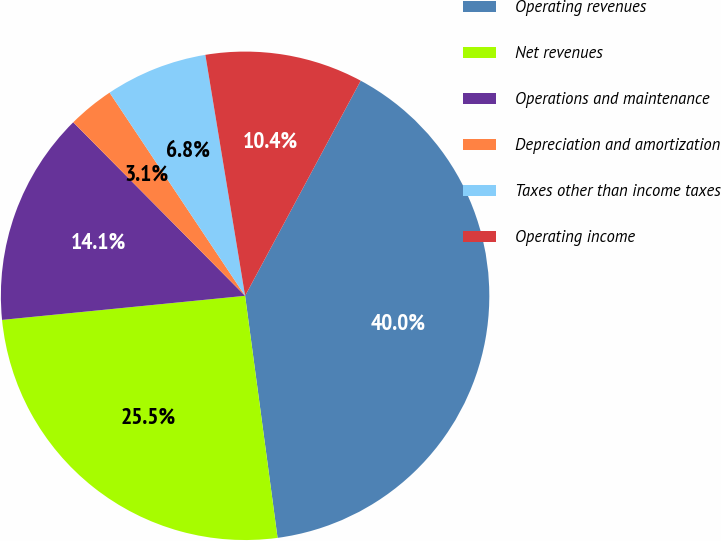<chart> <loc_0><loc_0><loc_500><loc_500><pie_chart><fcel>Operating revenues<fcel>Net revenues<fcel>Operations and maintenance<fcel>Depreciation and amortization<fcel>Taxes other than income taxes<fcel>Operating income<nl><fcel>40.03%<fcel>25.55%<fcel>14.15%<fcel>3.06%<fcel>6.76%<fcel>10.45%<nl></chart> 